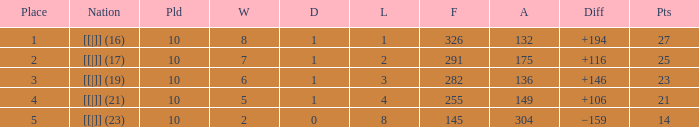Would you be able to parse every entry in this table? {'header': ['Place', 'Nation', 'Pld', 'W', 'D', 'L', 'F', 'A', 'Diff', 'Pts'], 'rows': [['1', '[[|]] (16)', '10', '8', '1', '1', '326', '132', '+194', '27'], ['2', '[[|]] (17)', '10', '7', '1', '2', '291', '175', '+116', '25'], ['3', '[[|]] (19)', '10', '6', '1', '3', '282', '136', '+146', '23'], ['4', '[[|]] (21)', '10', '5', '1', '4', '255', '149', '+106', '21'], ['5', '[[|]] (23)', '10', '2', '0', '8', '145', '304', '−159', '14']]}  How many games had a deficit of 175?  1.0. 